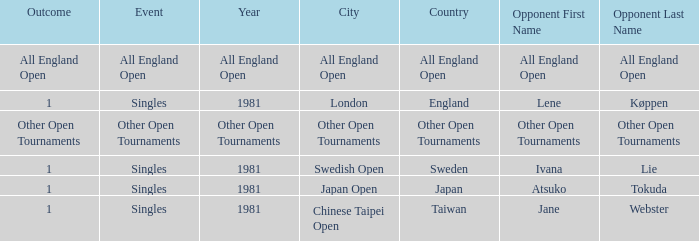Can you parse all the data within this table? {'header': ['Outcome', 'Event', 'Year', 'City', 'Country', 'Opponent First Name', 'Opponent Last Name'], 'rows': [['All England Open', 'All England Open', 'All England Open', 'All England Open', 'All England Open', 'All England Open', 'All England Open'], ['1', 'Singles', '1981', 'London', 'England', 'Lene', 'Køppen'], ['Other Open Tournaments', 'Other Open Tournaments', 'Other Open Tournaments', 'Other Open Tournaments', 'Other Open Tournaments', 'Other Open Tournaments', 'Other Open Tournaments'], ['1', 'Singles', '1981', 'Swedish Open', 'Sweden', 'Ivana', 'Lie'], ['1', 'Singles', '1981', 'Japan Open', 'Japan', 'Atsuko', 'Tokuda'], ['1', 'Singles', '1981', 'Chinese Taipei Open', 'Taiwan', 'Jane', 'Webster']]} What is the Opponent in final with an All England Open Outcome? All England Open. 